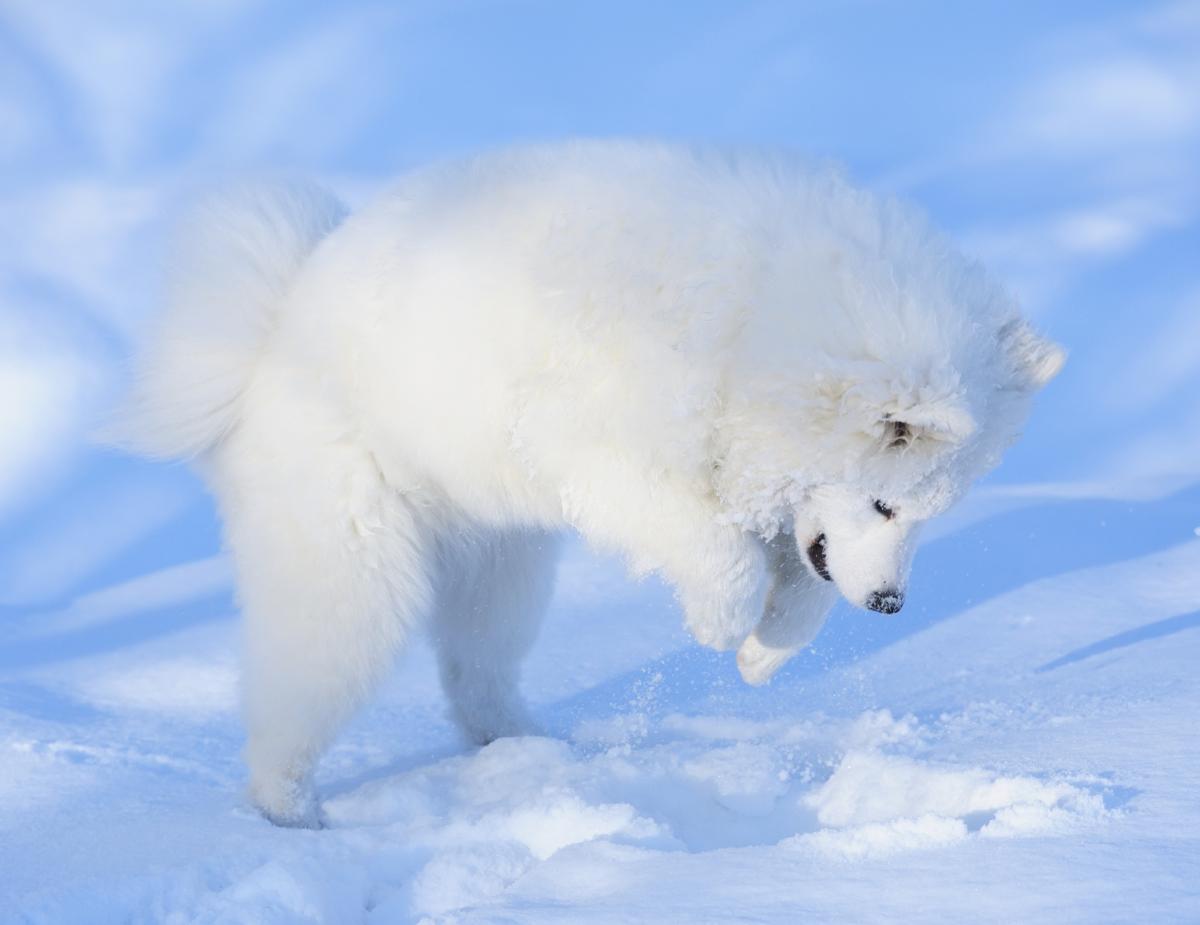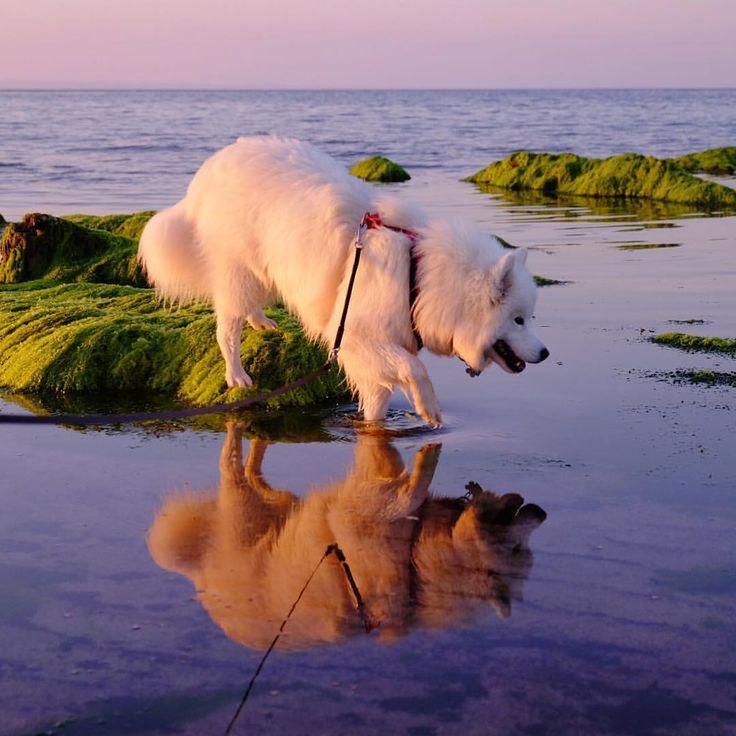The first image is the image on the left, the second image is the image on the right. Examine the images to the left and right. Is the description "One of the images shows a dog in snow." accurate? Answer yes or no. Yes. The first image is the image on the left, the second image is the image on the right. Evaluate the accuracy of this statement regarding the images: "An image shows one white dog in an arctic-type frozen scene.". Is it true? Answer yes or no. Yes. 